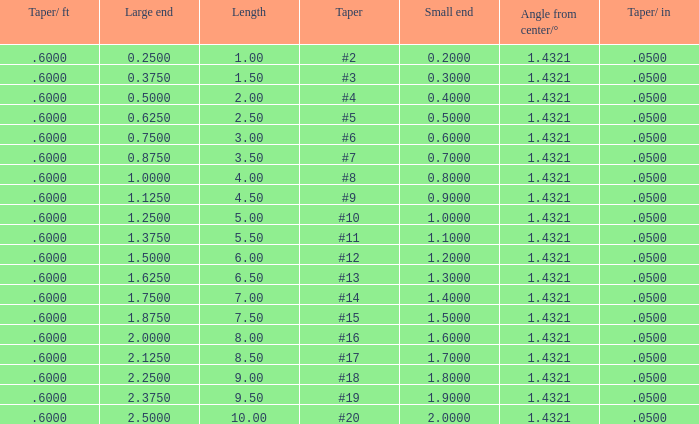Which Taper/ft that has a Large end smaller than 0.5, and a Taper of #2? 0.6. 